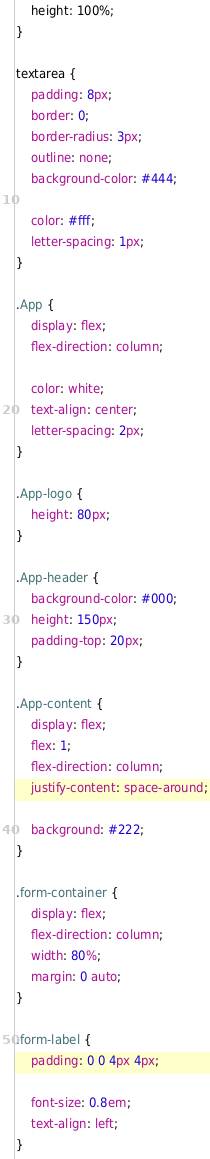<code> <loc_0><loc_0><loc_500><loc_500><_CSS_>    height: 100%;
}

textarea {
    padding: 8px;
    border: 0;
    border-radius: 3px;
    outline: none;
    background-color: #444;

    color: #fff;
    letter-spacing: 1px;
}

.App {
    display: flex;
    flex-direction: column;

    color: white;
    text-align: center;
    letter-spacing: 2px;
}

.App-logo {
    height: 80px;
}

.App-header {
    background-color: #000;
    height: 150px;
    padding-top: 20px;
}

.App-content {
    display: flex;
    flex: 1;
    flex-direction: column;
    justify-content: space-around;

    background: #222;
}

.form-container {
    display: flex;
    flex-direction: column;
    width: 80%;
    margin: 0 auto;
}

.form-label {
    padding: 0 0 4px 4px;

    font-size: 0.8em;
    text-align: left;
}
</code> 